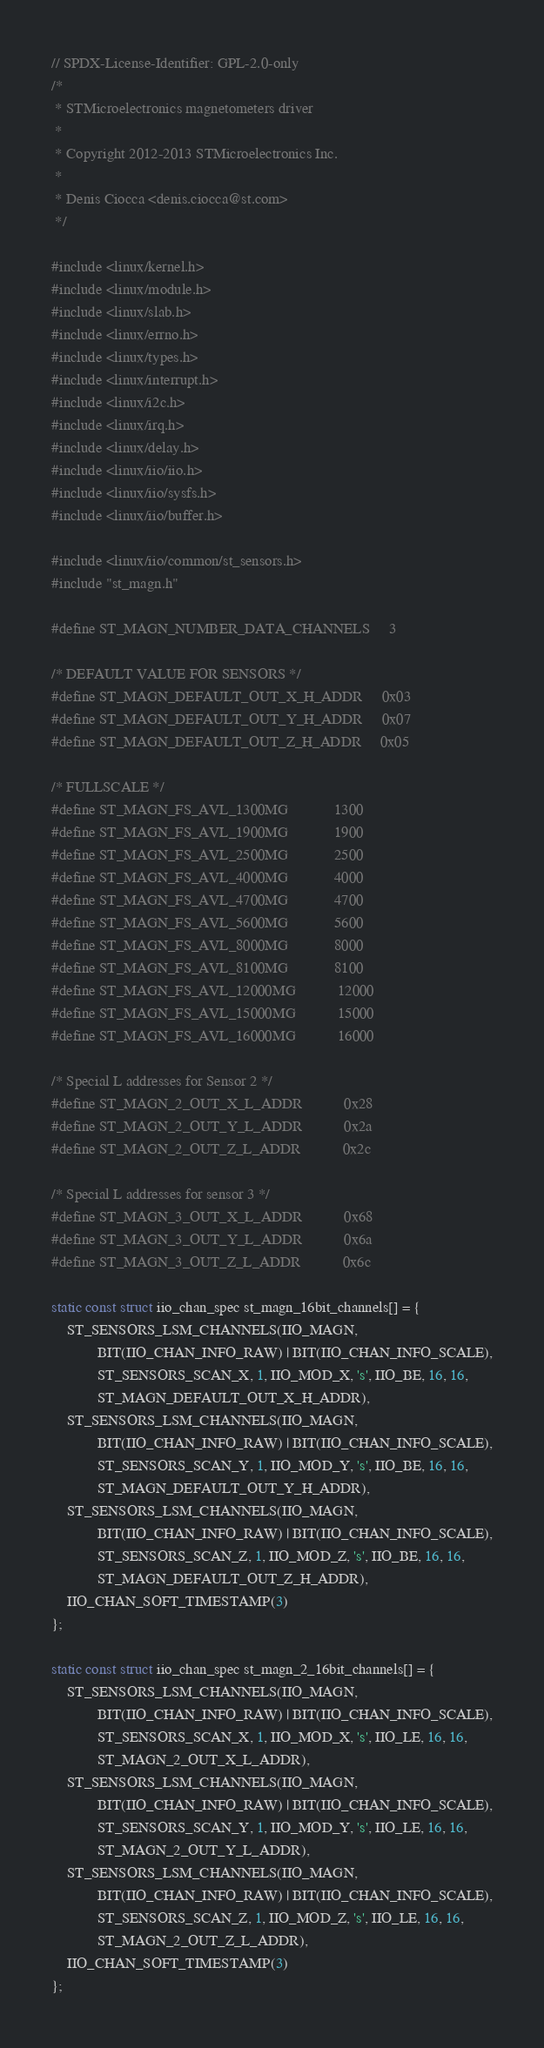Convert code to text. <code><loc_0><loc_0><loc_500><loc_500><_C_>// SPDX-License-Identifier: GPL-2.0-only
/*
 * STMicroelectronics magnetometers driver
 *
 * Copyright 2012-2013 STMicroelectronics Inc.
 *
 * Denis Ciocca <denis.ciocca@st.com>
 */

#include <linux/kernel.h>
#include <linux/module.h>
#include <linux/slab.h>
#include <linux/errno.h>
#include <linux/types.h>
#include <linux/interrupt.h>
#include <linux/i2c.h>
#include <linux/irq.h>
#include <linux/delay.h>
#include <linux/iio/iio.h>
#include <linux/iio/sysfs.h>
#include <linux/iio/buffer.h>

#include <linux/iio/common/st_sensors.h>
#include "st_magn.h"

#define ST_MAGN_NUMBER_DATA_CHANNELS		3

/* DEFAULT VALUE FOR SENSORS */
#define ST_MAGN_DEFAULT_OUT_X_H_ADDR		0x03
#define ST_MAGN_DEFAULT_OUT_Y_H_ADDR		0x07
#define ST_MAGN_DEFAULT_OUT_Z_H_ADDR		0x05

/* FULLSCALE */
#define ST_MAGN_FS_AVL_1300MG			1300
#define ST_MAGN_FS_AVL_1900MG			1900
#define ST_MAGN_FS_AVL_2500MG			2500
#define ST_MAGN_FS_AVL_4000MG			4000
#define ST_MAGN_FS_AVL_4700MG			4700
#define ST_MAGN_FS_AVL_5600MG			5600
#define ST_MAGN_FS_AVL_8000MG			8000
#define ST_MAGN_FS_AVL_8100MG			8100
#define ST_MAGN_FS_AVL_12000MG			12000
#define ST_MAGN_FS_AVL_15000MG			15000
#define ST_MAGN_FS_AVL_16000MG			16000

/* Special L addresses for Sensor 2 */
#define ST_MAGN_2_OUT_X_L_ADDR			0x28
#define ST_MAGN_2_OUT_Y_L_ADDR			0x2a
#define ST_MAGN_2_OUT_Z_L_ADDR			0x2c

/* Special L addresses for sensor 3 */
#define ST_MAGN_3_OUT_X_L_ADDR			0x68
#define ST_MAGN_3_OUT_Y_L_ADDR			0x6a
#define ST_MAGN_3_OUT_Z_L_ADDR			0x6c

static const struct iio_chan_spec st_magn_16bit_channels[] = {
	ST_SENSORS_LSM_CHANNELS(IIO_MAGN,
			BIT(IIO_CHAN_INFO_RAW) | BIT(IIO_CHAN_INFO_SCALE),
			ST_SENSORS_SCAN_X, 1, IIO_MOD_X, 's', IIO_BE, 16, 16,
			ST_MAGN_DEFAULT_OUT_X_H_ADDR),
	ST_SENSORS_LSM_CHANNELS(IIO_MAGN,
			BIT(IIO_CHAN_INFO_RAW) | BIT(IIO_CHAN_INFO_SCALE),
			ST_SENSORS_SCAN_Y, 1, IIO_MOD_Y, 's', IIO_BE, 16, 16,
			ST_MAGN_DEFAULT_OUT_Y_H_ADDR),
	ST_SENSORS_LSM_CHANNELS(IIO_MAGN,
			BIT(IIO_CHAN_INFO_RAW) | BIT(IIO_CHAN_INFO_SCALE),
			ST_SENSORS_SCAN_Z, 1, IIO_MOD_Z, 's', IIO_BE, 16, 16,
			ST_MAGN_DEFAULT_OUT_Z_H_ADDR),
	IIO_CHAN_SOFT_TIMESTAMP(3)
};

static const struct iio_chan_spec st_magn_2_16bit_channels[] = {
	ST_SENSORS_LSM_CHANNELS(IIO_MAGN,
			BIT(IIO_CHAN_INFO_RAW) | BIT(IIO_CHAN_INFO_SCALE),
			ST_SENSORS_SCAN_X, 1, IIO_MOD_X, 's', IIO_LE, 16, 16,
			ST_MAGN_2_OUT_X_L_ADDR),
	ST_SENSORS_LSM_CHANNELS(IIO_MAGN,
			BIT(IIO_CHAN_INFO_RAW) | BIT(IIO_CHAN_INFO_SCALE),
			ST_SENSORS_SCAN_Y, 1, IIO_MOD_Y, 's', IIO_LE, 16, 16,
			ST_MAGN_2_OUT_Y_L_ADDR),
	ST_SENSORS_LSM_CHANNELS(IIO_MAGN,
			BIT(IIO_CHAN_INFO_RAW) | BIT(IIO_CHAN_INFO_SCALE),
			ST_SENSORS_SCAN_Z, 1, IIO_MOD_Z, 's', IIO_LE, 16, 16,
			ST_MAGN_2_OUT_Z_L_ADDR),
	IIO_CHAN_SOFT_TIMESTAMP(3)
};
</code> 